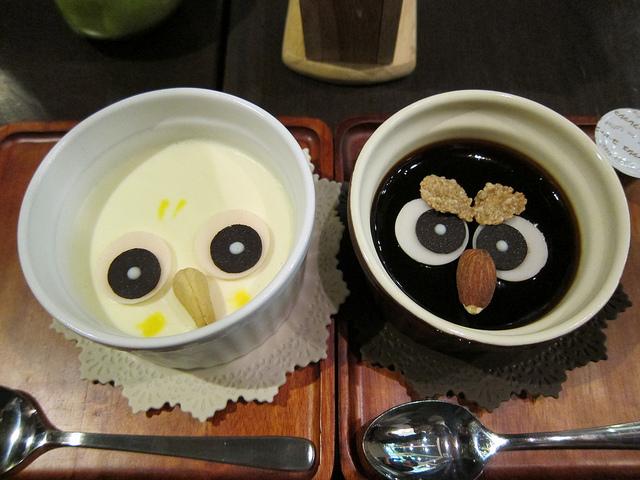What are the eyes made out of?
Short answer required. Candy. What shape is in the coffee?
Write a very short answer. Owl. Are these edible?
Write a very short answer. Yes. What food makes the nose?
Short answer required. Nuts. 